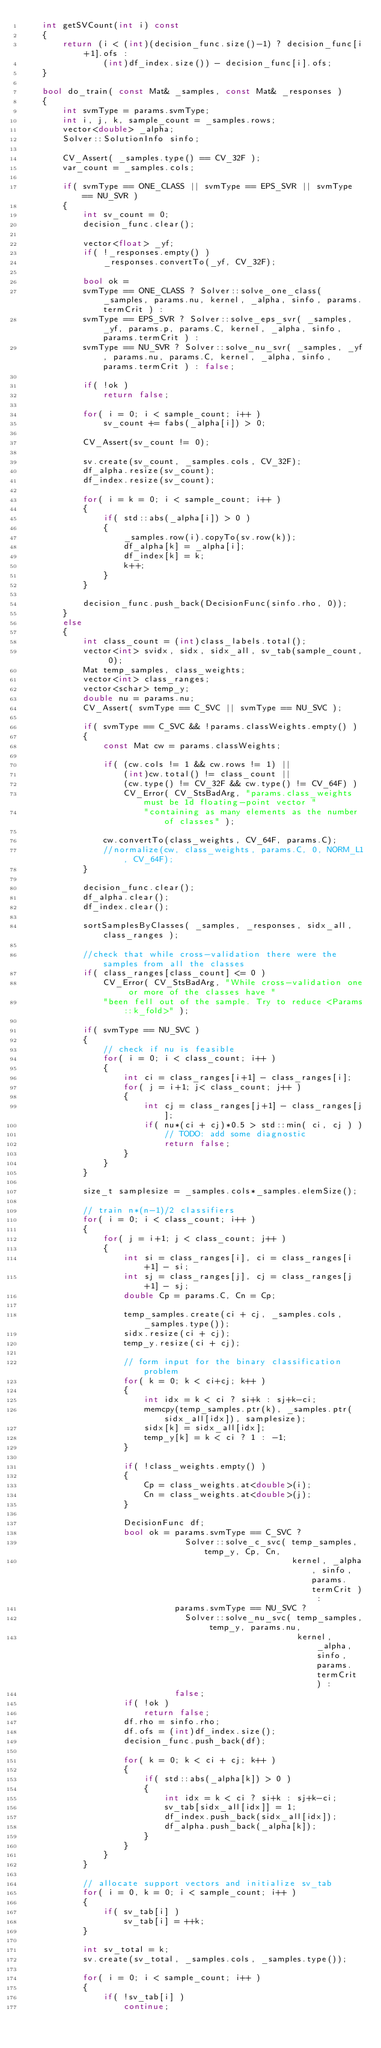Convert code to text. <code><loc_0><loc_0><loc_500><loc_500><_C++_>    int getSVCount(int i) const
    {
        return (i < (int)(decision_func.size()-1) ? decision_func[i+1].ofs :
                (int)df_index.size()) - decision_func[i].ofs;
    }

    bool do_train( const Mat& _samples, const Mat& _responses )
    {
        int svmType = params.svmType;
        int i, j, k, sample_count = _samples.rows;
        vector<double> _alpha;
        Solver::SolutionInfo sinfo;

        CV_Assert( _samples.type() == CV_32F );
        var_count = _samples.cols;

        if( svmType == ONE_CLASS || svmType == EPS_SVR || svmType == NU_SVR )
        {
            int sv_count = 0;
            decision_func.clear();

            vector<float> _yf;
            if( !_responses.empty() )
                _responses.convertTo(_yf, CV_32F);

            bool ok =
            svmType == ONE_CLASS ? Solver::solve_one_class( _samples, params.nu, kernel, _alpha, sinfo, params.termCrit ) :
            svmType == EPS_SVR ? Solver::solve_eps_svr( _samples, _yf, params.p, params.C, kernel, _alpha, sinfo, params.termCrit ) :
            svmType == NU_SVR ? Solver::solve_nu_svr( _samples, _yf, params.nu, params.C, kernel, _alpha, sinfo, params.termCrit ) : false;

            if( !ok )
                return false;

            for( i = 0; i < sample_count; i++ )
                sv_count += fabs(_alpha[i]) > 0;

            CV_Assert(sv_count != 0);

            sv.create(sv_count, _samples.cols, CV_32F);
            df_alpha.resize(sv_count);
            df_index.resize(sv_count);

            for( i = k = 0; i < sample_count; i++ )
            {
                if( std::abs(_alpha[i]) > 0 )
                {
                    _samples.row(i).copyTo(sv.row(k));
                    df_alpha[k] = _alpha[i];
                    df_index[k] = k;
                    k++;
                }
            }

            decision_func.push_back(DecisionFunc(sinfo.rho, 0));
        }
        else
        {
            int class_count = (int)class_labels.total();
            vector<int> svidx, sidx, sidx_all, sv_tab(sample_count, 0);
            Mat temp_samples, class_weights;
            vector<int> class_ranges;
            vector<schar> temp_y;
            double nu = params.nu;
            CV_Assert( svmType == C_SVC || svmType == NU_SVC );

            if( svmType == C_SVC && !params.classWeights.empty() )
            {
                const Mat cw = params.classWeights;

                if( (cw.cols != 1 && cw.rows != 1) ||
                    (int)cw.total() != class_count ||
                    (cw.type() != CV_32F && cw.type() != CV_64F) )
                    CV_Error( CV_StsBadArg, "params.class_weights must be 1d floating-point vector "
                        "containing as many elements as the number of classes" );

                cw.convertTo(class_weights, CV_64F, params.C);
                //normalize(cw, class_weights, params.C, 0, NORM_L1, CV_64F);
            }

            decision_func.clear();
            df_alpha.clear();
            df_index.clear();

            sortSamplesByClasses( _samples, _responses, sidx_all, class_ranges );

            //check that while cross-validation there were the samples from all the classes
            if( class_ranges[class_count] <= 0 )
                CV_Error( CV_StsBadArg, "While cross-validation one or more of the classes have "
                "been fell out of the sample. Try to reduce <Params::k_fold>" );

            if( svmType == NU_SVC )
            {
                // check if nu is feasible
                for( i = 0; i < class_count; i++ )
                {
                    int ci = class_ranges[i+1] - class_ranges[i];
                    for( j = i+1; j< class_count; j++ )
                    {
                        int cj = class_ranges[j+1] - class_ranges[j];
                        if( nu*(ci + cj)*0.5 > std::min( ci, cj ) )
                            // TODO: add some diagnostic
                            return false;
                    }
                }
            }

            size_t samplesize = _samples.cols*_samples.elemSize();

            // train n*(n-1)/2 classifiers
            for( i = 0; i < class_count; i++ )
            {
                for( j = i+1; j < class_count; j++ )
                {
                    int si = class_ranges[i], ci = class_ranges[i+1] - si;
                    int sj = class_ranges[j], cj = class_ranges[j+1] - sj;
                    double Cp = params.C, Cn = Cp;

                    temp_samples.create(ci + cj, _samples.cols, _samples.type());
                    sidx.resize(ci + cj);
                    temp_y.resize(ci + cj);

                    // form input for the binary classification problem
                    for( k = 0; k < ci+cj; k++ )
                    {
                        int idx = k < ci ? si+k : sj+k-ci;
                        memcpy(temp_samples.ptr(k), _samples.ptr(sidx_all[idx]), samplesize);
                        sidx[k] = sidx_all[idx];
                        temp_y[k] = k < ci ? 1 : -1;
                    }

                    if( !class_weights.empty() )
                    {
                        Cp = class_weights.at<double>(i);
                        Cn = class_weights.at<double>(j);
                    }

                    DecisionFunc df;
                    bool ok = params.svmType == C_SVC ?
                                Solver::solve_c_svc( temp_samples, temp_y, Cp, Cn,
                                                     kernel, _alpha, sinfo, params.termCrit ) :
                              params.svmType == NU_SVC ?
                                Solver::solve_nu_svc( temp_samples, temp_y, params.nu,
                                                      kernel, _alpha, sinfo, params.termCrit ) :
                              false;
                    if( !ok )
                        return false;
                    df.rho = sinfo.rho;
                    df.ofs = (int)df_index.size();
                    decision_func.push_back(df);

                    for( k = 0; k < ci + cj; k++ )
                    {
                        if( std::abs(_alpha[k]) > 0 )
                        {
                            int idx = k < ci ? si+k : sj+k-ci;
                            sv_tab[sidx_all[idx]] = 1;
                            df_index.push_back(sidx_all[idx]);
                            df_alpha.push_back(_alpha[k]);
                        }
                    }
                }
            }

            // allocate support vectors and initialize sv_tab
            for( i = 0, k = 0; i < sample_count; i++ )
            {
                if( sv_tab[i] )
                    sv_tab[i] = ++k;
            }

            int sv_total = k;
            sv.create(sv_total, _samples.cols, _samples.type());

            for( i = 0; i < sample_count; i++ )
            {
                if( !sv_tab[i] )
                    continue;</code> 